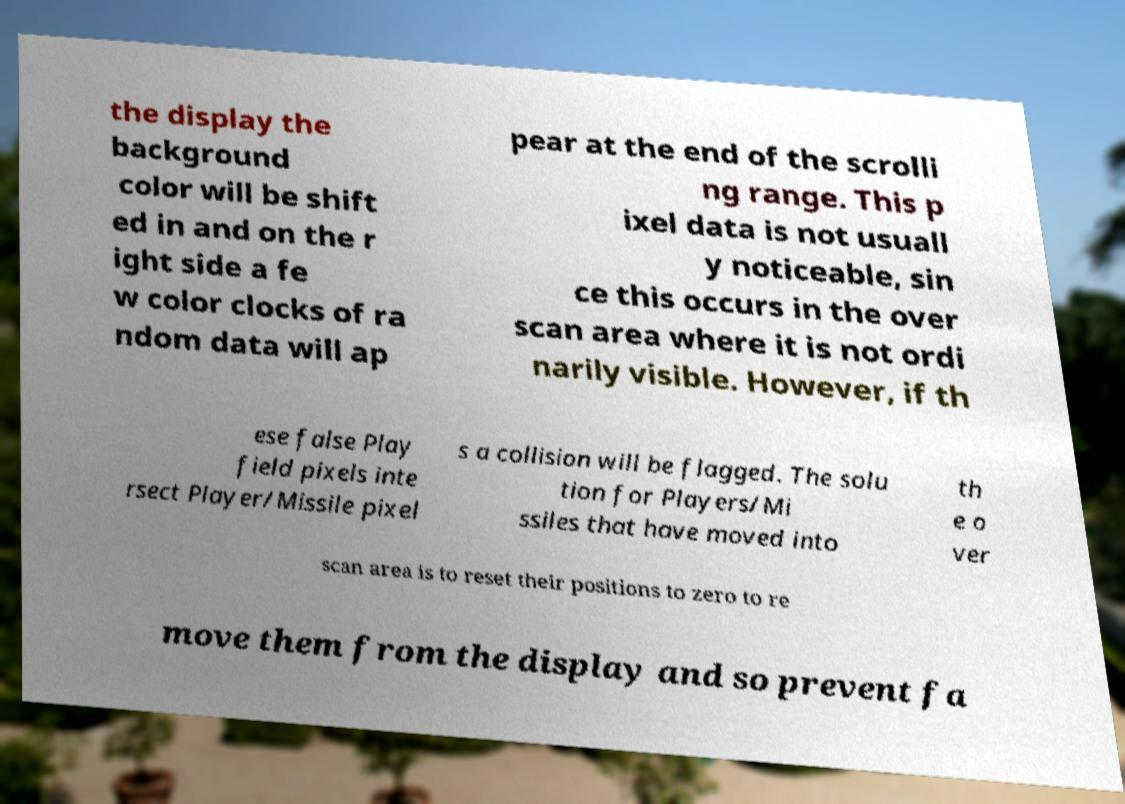What messages or text are displayed in this image? I need them in a readable, typed format. the display the background color will be shift ed in and on the r ight side a fe w color clocks of ra ndom data will ap pear at the end of the scrolli ng range. This p ixel data is not usuall y noticeable, sin ce this occurs in the over scan area where it is not ordi narily visible. However, if th ese false Play field pixels inte rsect Player/Missile pixel s a collision will be flagged. The solu tion for Players/Mi ssiles that have moved into th e o ver scan area is to reset their positions to zero to re move them from the display and so prevent fa 